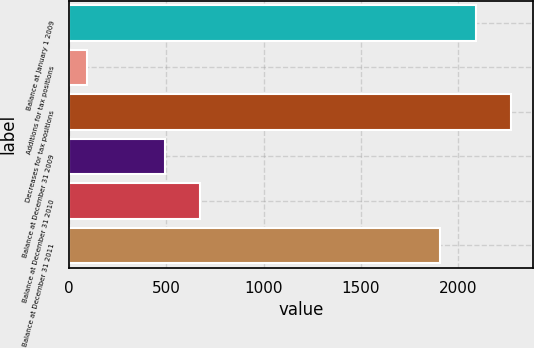Convert chart. <chart><loc_0><loc_0><loc_500><loc_500><bar_chart><fcel>Balance at January 1 2009<fcel>Additions for tax positions<fcel>Decreases for tax positions<fcel>Balance at December 31 2009<fcel>Balance at December 31 2010<fcel>Balance at December 31 2011<nl><fcel>2092.3<fcel>89<fcel>2274.6<fcel>490.3<fcel>672.6<fcel>1910<nl></chart> 